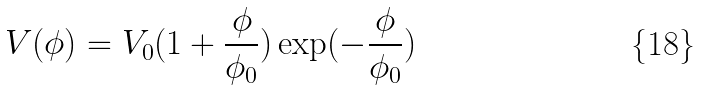Convert formula to latex. <formula><loc_0><loc_0><loc_500><loc_500>V ( \phi ) = V _ { 0 } ( 1 + \frac { \phi } { \phi _ { 0 } } ) \exp ( - \frac { \phi } { \phi _ { 0 } } )</formula> 